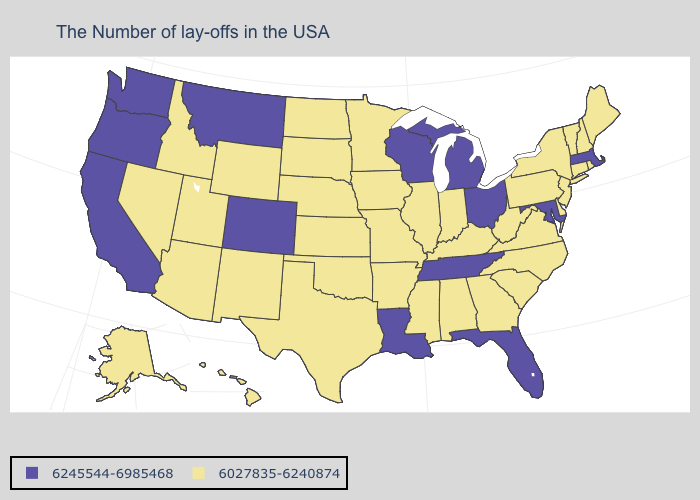What is the lowest value in the Northeast?
Short answer required. 6027835-6240874. Name the states that have a value in the range 6027835-6240874?
Answer briefly. Maine, Rhode Island, New Hampshire, Vermont, Connecticut, New York, New Jersey, Delaware, Pennsylvania, Virginia, North Carolina, South Carolina, West Virginia, Georgia, Kentucky, Indiana, Alabama, Illinois, Mississippi, Missouri, Arkansas, Minnesota, Iowa, Kansas, Nebraska, Oklahoma, Texas, South Dakota, North Dakota, Wyoming, New Mexico, Utah, Arizona, Idaho, Nevada, Alaska, Hawaii. Name the states that have a value in the range 6027835-6240874?
Quick response, please. Maine, Rhode Island, New Hampshire, Vermont, Connecticut, New York, New Jersey, Delaware, Pennsylvania, Virginia, North Carolina, South Carolina, West Virginia, Georgia, Kentucky, Indiana, Alabama, Illinois, Mississippi, Missouri, Arkansas, Minnesota, Iowa, Kansas, Nebraska, Oklahoma, Texas, South Dakota, North Dakota, Wyoming, New Mexico, Utah, Arizona, Idaho, Nevada, Alaska, Hawaii. Does the first symbol in the legend represent the smallest category?
Keep it brief. No. Does Missouri have a lower value than Michigan?
Give a very brief answer. Yes. Among the states that border Iowa , does Missouri have the lowest value?
Give a very brief answer. Yes. What is the value of New Jersey?
Keep it brief. 6027835-6240874. What is the highest value in the South ?
Be succinct. 6245544-6985468. Name the states that have a value in the range 6027835-6240874?
Keep it brief. Maine, Rhode Island, New Hampshire, Vermont, Connecticut, New York, New Jersey, Delaware, Pennsylvania, Virginia, North Carolina, South Carolina, West Virginia, Georgia, Kentucky, Indiana, Alabama, Illinois, Mississippi, Missouri, Arkansas, Minnesota, Iowa, Kansas, Nebraska, Oklahoma, Texas, South Dakota, North Dakota, Wyoming, New Mexico, Utah, Arizona, Idaho, Nevada, Alaska, Hawaii. Name the states that have a value in the range 6245544-6985468?
Answer briefly. Massachusetts, Maryland, Ohio, Florida, Michigan, Tennessee, Wisconsin, Louisiana, Colorado, Montana, California, Washington, Oregon. What is the value of Rhode Island?
Keep it brief. 6027835-6240874. Does the map have missing data?
Write a very short answer. No. What is the highest value in the USA?
Write a very short answer. 6245544-6985468. Does Massachusetts have the lowest value in the Northeast?
Short answer required. No. Name the states that have a value in the range 6245544-6985468?
Answer briefly. Massachusetts, Maryland, Ohio, Florida, Michigan, Tennessee, Wisconsin, Louisiana, Colorado, Montana, California, Washington, Oregon. 